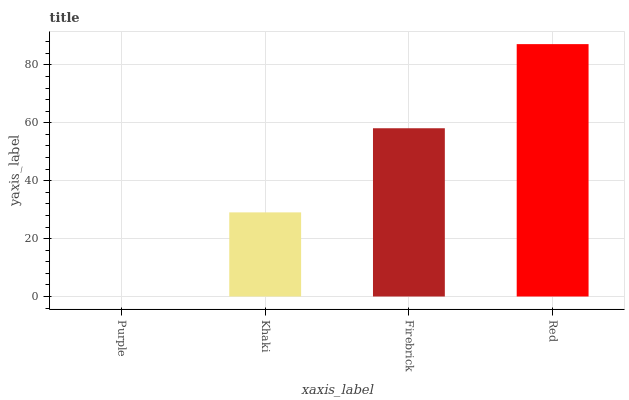Is Purple the minimum?
Answer yes or no. Yes. Is Red the maximum?
Answer yes or no. Yes. Is Khaki the minimum?
Answer yes or no. No. Is Khaki the maximum?
Answer yes or no. No. Is Khaki greater than Purple?
Answer yes or no. Yes. Is Purple less than Khaki?
Answer yes or no. Yes. Is Purple greater than Khaki?
Answer yes or no. No. Is Khaki less than Purple?
Answer yes or no. No. Is Firebrick the high median?
Answer yes or no. Yes. Is Khaki the low median?
Answer yes or no. Yes. Is Red the high median?
Answer yes or no. No. Is Purple the low median?
Answer yes or no. No. 